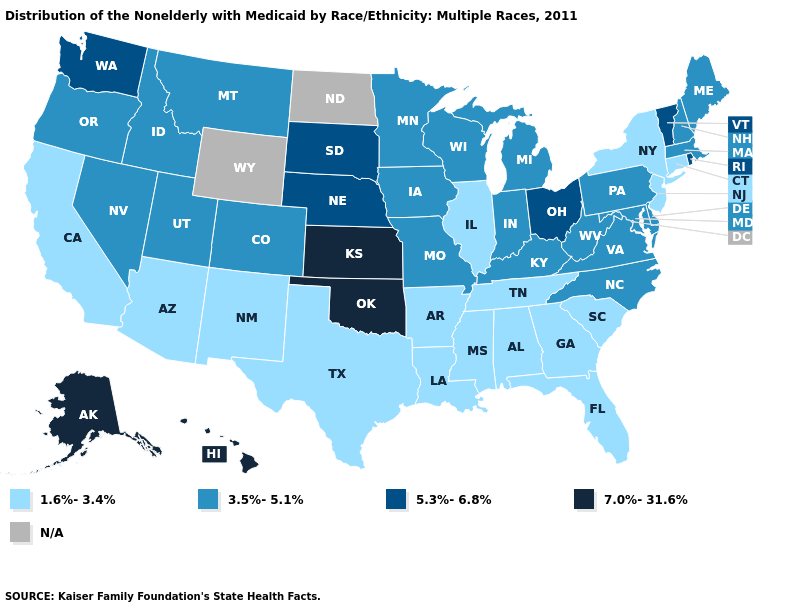How many symbols are there in the legend?
Quick response, please. 5. What is the value of Alabama?
Write a very short answer. 1.6%-3.4%. What is the value of Louisiana?
Concise answer only. 1.6%-3.4%. Does Iowa have the lowest value in the MidWest?
Quick response, please. No. Name the states that have a value in the range 1.6%-3.4%?
Answer briefly. Alabama, Arizona, Arkansas, California, Connecticut, Florida, Georgia, Illinois, Louisiana, Mississippi, New Jersey, New Mexico, New York, South Carolina, Tennessee, Texas. Does Utah have the lowest value in the West?
Concise answer only. No. Name the states that have a value in the range 5.3%-6.8%?
Be succinct. Nebraska, Ohio, Rhode Island, South Dakota, Vermont, Washington. Name the states that have a value in the range 7.0%-31.6%?
Give a very brief answer. Alaska, Hawaii, Kansas, Oklahoma. Does Arkansas have the lowest value in the South?
Concise answer only. Yes. Does the map have missing data?
Answer briefly. Yes. What is the value of South Dakota?
Concise answer only. 5.3%-6.8%. Does the map have missing data?
Short answer required. Yes. What is the highest value in states that border Pennsylvania?
Keep it brief. 5.3%-6.8%. What is the lowest value in states that border Kentucky?
Quick response, please. 1.6%-3.4%. 